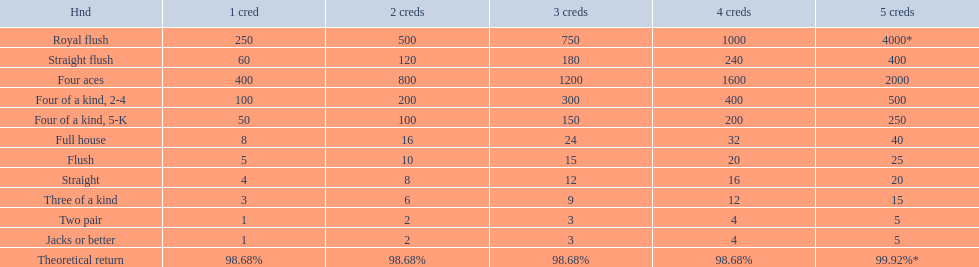What are the hands? Royal flush, Straight flush, Four aces, Four of a kind, 2-4, Four of a kind, 5-K, Full house, Flush, Straight, Three of a kind, Two pair, Jacks or better. Which hand is on the top? Royal flush. 